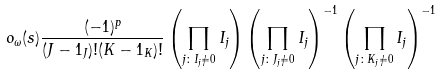Convert formula to latex. <formula><loc_0><loc_0><loc_500><loc_500>o _ { \omega } ( s ) \frac { ( - 1 ) ^ { p } } { ( J - 1 _ { J } ) ! ( K - 1 _ { K } ) ! } \left ( \prod _ { j \colon I _ { j } \neq 0 } I _ { j } \right ) \left ( \prod _ { j \colon J _ { j } \neq 0 } I _ { j } \right ) ^ { - 1 } \left ( \prod _ { j \colon K _ { j } \neq 0 } I _ { j } \right ) ^ { - 1 }</formula> 